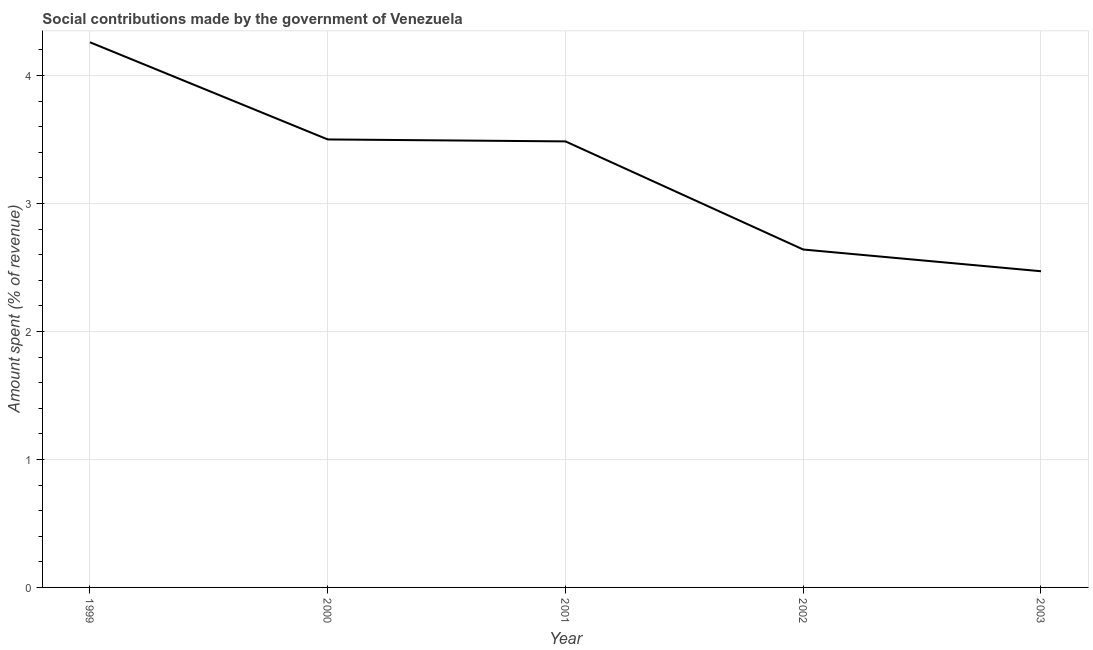What is the amount spent in making social contributions in 2000?
Offer a very short reply. 3.5. Across all years, what is the maximum amount spent in making social contributions?
Ensure brevity in your answer.  4.26. Across all years, what is the minimum amount spent in making social contributions?
Offer a terse response. 2.47. In which year was the amount spent in making social contributions maximum?
Ensure brevity in your answer.  1999. What is the sum of the amount spent in making social contributions?
Your answer should be compact. 16.36. What is the difference between the amount spent in making social contributions in 2001 and 2003?
Offer a terse response. 1.01. What is the average amount spent in making social contributions per year?
Provide a short and direct response. 3.27. What is the median amount spent in making social contributions?
Your answer should be very brief. 3.49. In how many years, is the amount spent in making social contributions greater than 3.4 %?
Ensure brevity in your answer.  3. What is the ratio of the amount spent in making social contributions in 2002 to that in 2003?
Provide a short and direct response. 1.07. Is the difference between the amount spent in making social contributions in 1999 and 2000 greater than the difference between any two years?
Ensure brevity in your answer.  No. What is the difference between the highest and the second highest amount spent in making social contributions?
Ensure brevity in your answer.  0.76. What is the difference between the highest and the lowest amount spent in making social contributions?
Your answer should be very brief. 1.79. Does the amount spent in making social contributions monotonically increase over the years?
Offer a terse response. No. How many lines are there?
Your answer should be very brief. 1. Are the values on the major ticks of Y-axis written in scientific E-notation?
Provide a short and direct response. No. Does the graph contain any zero values?
Offer a terse response. No. Does the graph contain grids?
Provide a short and direct response. Yes. What is the title of the graph?
Ensure brevity in your answer.  Social contributions made by the government of Venezuela. What is the label or title of the X-axis?
Your response must be concise. Year. What is the label or title of the Y-axis?
Provide a short and direct response. Amount spent (% of revenue). What is the Amount spent (% of revenue) of 1999?
Keep it short and to the point. 4.26. What is the Amount spent (% of revenue) in 2000?
Give a very brief answer. 3.5. What is the Amount spent (% of revenue) in 2001?
Give a very brief answer. 3.49. What is the Amount spent (% of revenue) in 2002?
Provide a succinct answer. 2.64. What is the Amount spent (% of revenue) in 2003?
Keep it short and to the point. 2.47. What is the difference between the Amount spent (% of revenue) in 1999 and 2000?
Your answer should be very brief. 0.76. What is the difference between the Amount spent (% of revenue) in 1999 and 2001?
Make the answer very short. 0.77. What is the difference between the Amount spent (% of revenue) in 1999 and 2002?
Keep it short and to the point. 1.62. What is the difference between the Amount spent (% of revenue) in 1999 and 2003?
Make the answer very short. 1.79. What is the difference between the Amount spent (% of revenue) in 2000 and 2001?
Make the answer very short. 0.02. What is the difference between the Amount spent (% of revenue) in 2000 and 2002?
Your answer should be very brief. 0.86. What is the difference between the Amount spent (% of revenue) in 2000 and 2003?
Your response must be concise. 1.03. What is the difference between the Amount spent (% of revenue) in 2001 and 2002?
Your response must be concise. 0.84. What is the difference between the Amount spent (% of revenue) in 2001 and 2003?
Give a very brief answer. 1.01. What is the difference between the Amount spent (% of revenue) in 2002 and 2003?
Ensure brevity in your answer.  0.17. What is the ratio of the Amount spent (% of revenue) in 1999 to that in 2000?
Your answer should be very brief. 1.22. What is the ratio of the Amount spent (% of revenue) in 1999 to that in 2001?
Provide a short and direct response. 1.22. What is the ratio of the Amount spent (% of revenue) in 1999 to that in 2002?
Your answer should be compact. 1.61. What is the ratio of the Amount spent (% of revenue) in 1999 to that in 2003?
Keep it short and to the point. 1.72. What is the ratio of the Amount spent (% of revenue) in 2000 to that in 2002?
Your answer should be compact. 1.33. What is the ratio of the Amount spent (% of revenue) in 2000 to that in 2003?
Your answer should be very brief. 1.42. What is the ratio of the Amount spent (% of revenue) in 2001 to that in 2002?
Keep it short and to the point. 1.32. What is the ratio of the Amount spent (% of revenue) in 2001 to that in 2003?
Provide a short and direct response. 1.41. What is the ratio of the Amount spent (% of revenue) in 2002 to that in 2003?
Offer a very short reply. 1.07. 